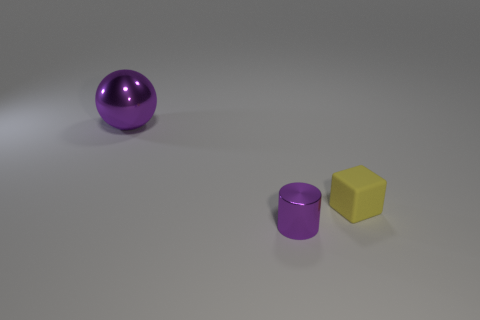Add 3 big brown cubes. How many objects exist? 6 Subtract all cylinders. How many objects are left? 2 Subtract all red cylinders. Subtract all blue blocks. How many cylinders are left? 1 Subtract all tiny objects. Subtract all tiny yellow matte cubes. How many objects are left? 0 Add 1 yellow things. How many yellow things are left? 2 Add 1 large shiny things. How many large shiny things exist? 2 Subtract 0 red cylinders. How many objects are left? 3 